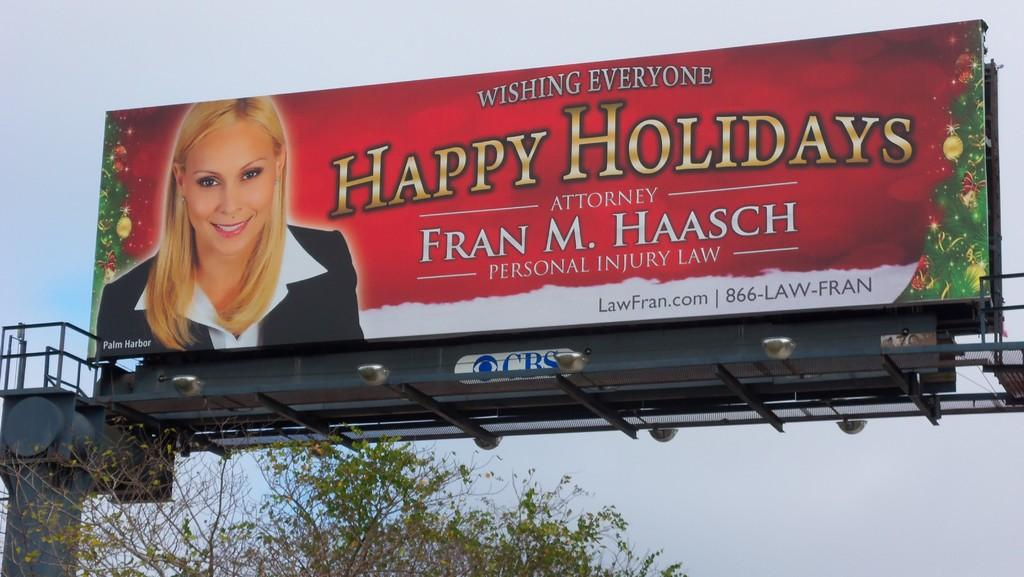<image>
Share a concise interpretation of the image provided. a billboard with a ad by Fram M. Haasch on it 